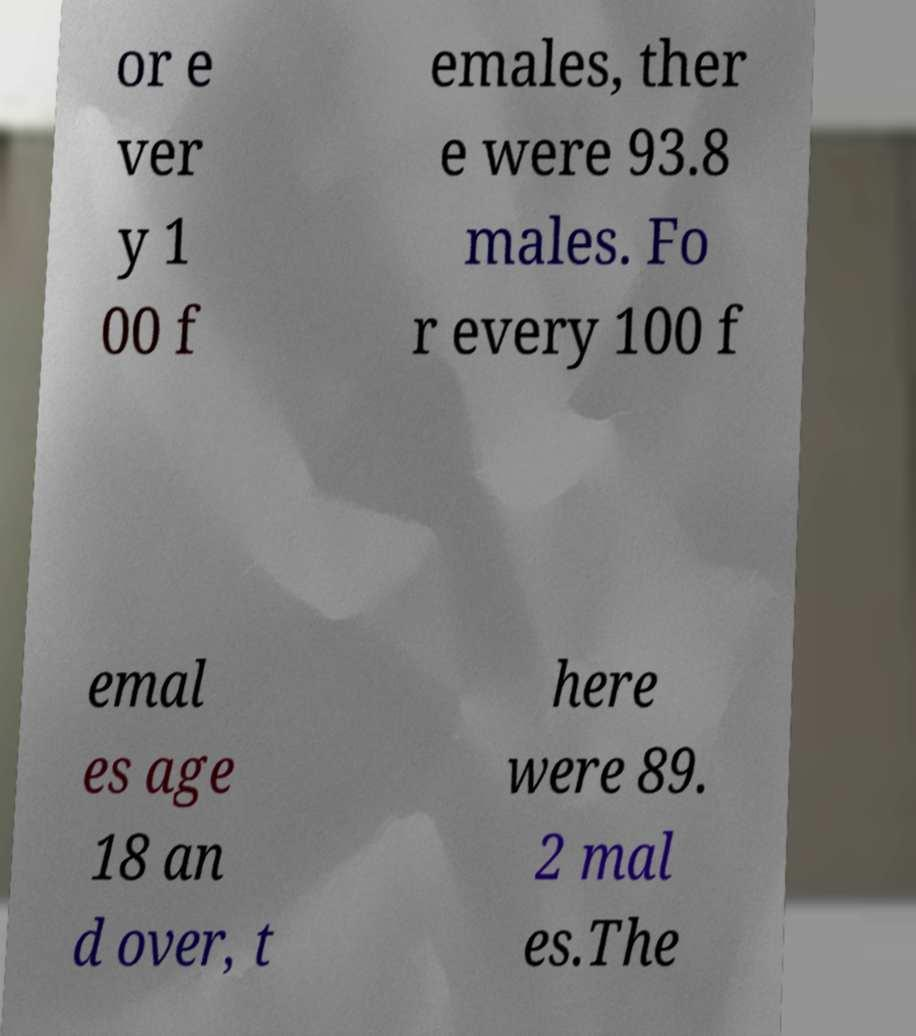I need the written content from this picture converted into text. Can you do that? or e ver y 1 00 f emales, ther e were 93.8 males. Fo r every 100 f emal es age 18 an d over, t here were 89. 2 mal es.The 